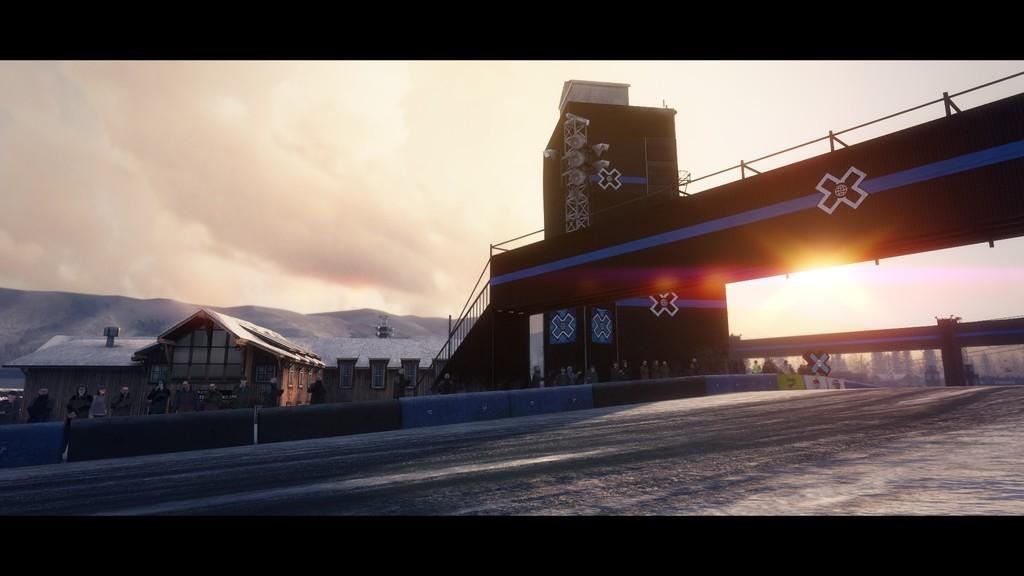What type of structure is in the image? There is a foot over bridge in the image. What else can be seen in the background of the image? Houses, trees, hills, and a cloudy sky are visible in the image. What is the condition of the road in the image? Snow is present on the road in the image. What type of orange is being harvested in the image? There is no orange or any indication of orange harvesting in the image. What industry can be seen operating near the foot over bridge in the image? There is no industry visible in the image; it primarily features natural elements and a foot over bridge. What type of ship can be seen sailing near the foot over bridge in the image? There is no ship visible in the image; it primarily features natural elements and a foot over bridge. 